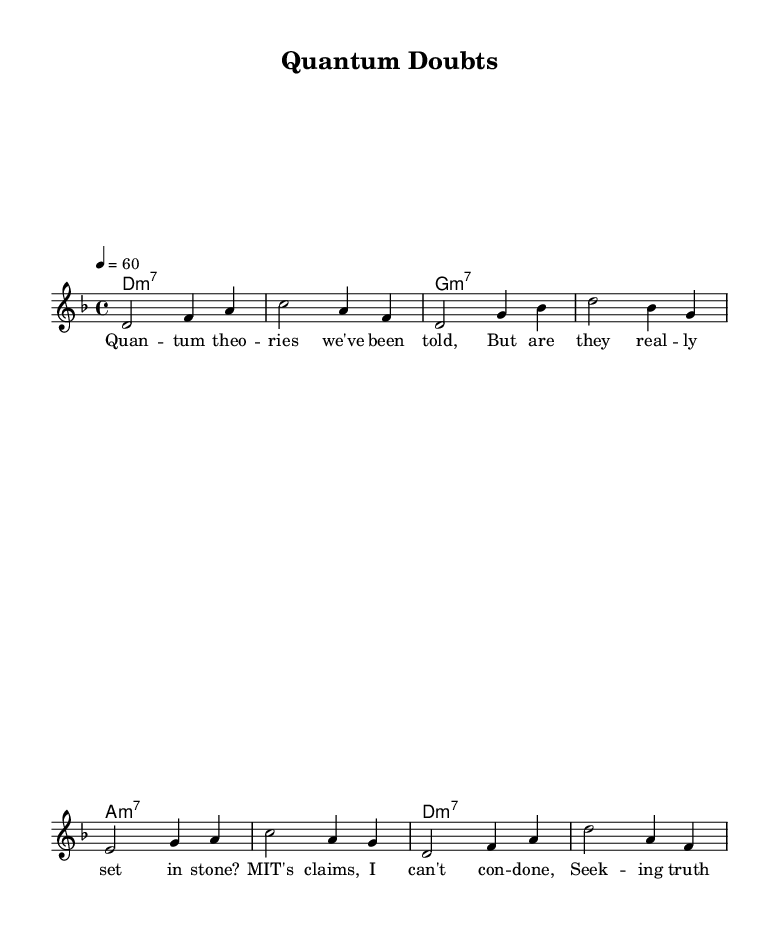What is the key signature of this music? The key signature is determined by the given note names and their corresponding sharps or flats. In this case, the music is in D minor, indicated by the key signature having one flat (B flat).
Answer: D minor What is the time signature? The time signature is indicated at the beginning of the score and shows how many beats are in each measure. Here, it is 4/4, meaning there are four beats per measure.
Answer: 4/4 What is the tempo marking? The tempo is indicated at the beginning of the score with a number followed by ' = ' and it shows the speed of the music. In this score, the tempo is set at 60 beats per minute.
Answer: 60 How many measures are in the piece? By counting the number of groups of notes separated by vertical lines (bar lines), we find there are a total of 8 measures in the piece.
Answer: 8 measures Which chords are used in this piece? The chords are highlighted in the 'ChordNames' section of the music sheet. This piece primarily uses D minor 7, G minor 7, and A minor 7 chords.
Answer: D minor 7, G minor 7, A minor 7 What theme does the song explore? The lyrics indicate the song's theme revolves around questioning established theories in quantum physics, specifically critiquing claims made by MIT.
Answer: Quantum physics skepticism 